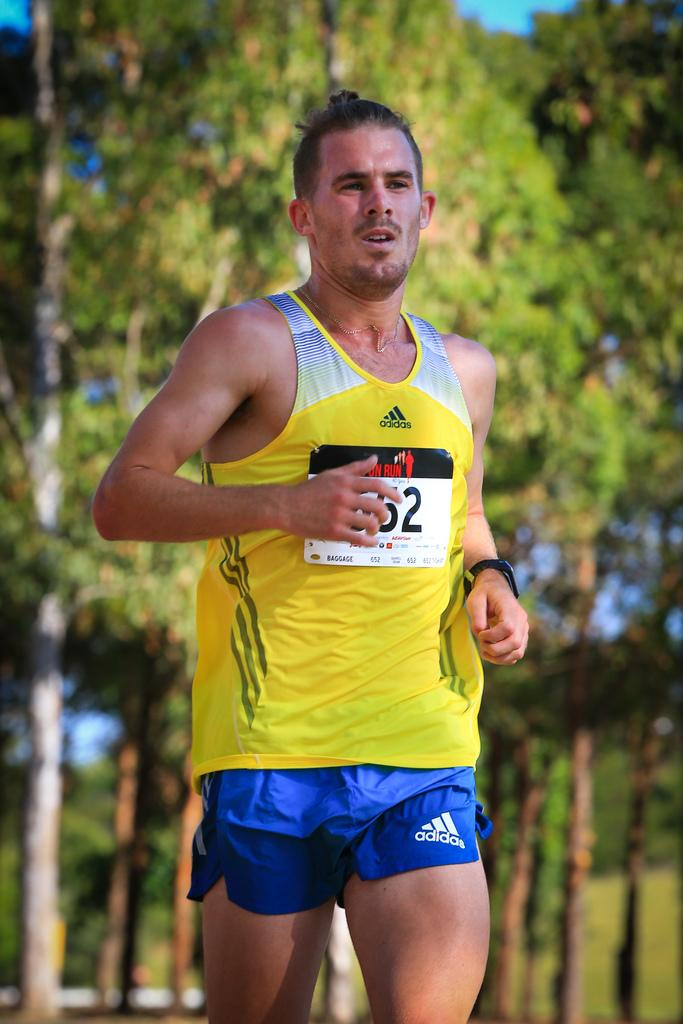Provide a one-sentence caption for the provided image. A man running with a yellow shirt and blue shorts from Adidas. 